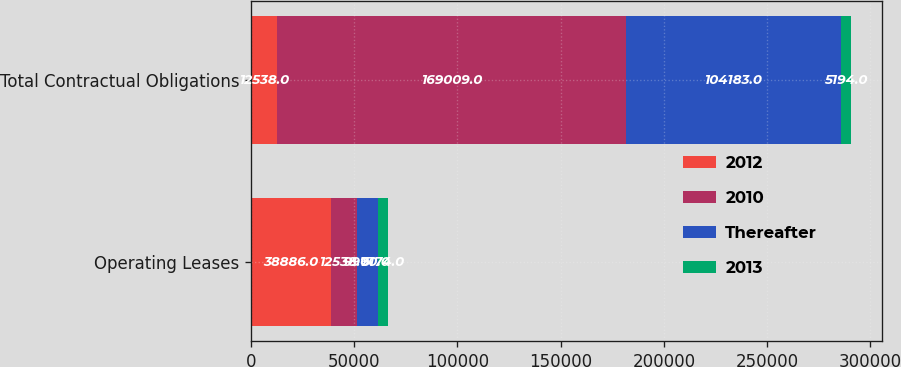Convert chart to OTSL. <chart><loc_0><loc_0><loc_500><loc_500><stacked_bar_chart><ecel><fcel>Operating Leases<fcel>Total Contractual Obligations<nl><fcel>2012<fcel>38886<fcel>12538<nl><fcel>2010<fcel>12538<fcel>169009<nl><fcel>Thereafter<fcel>9970<fcel>104183<nl><fcel>2013<fcel>5174<fcel>5194<nl></chart> 